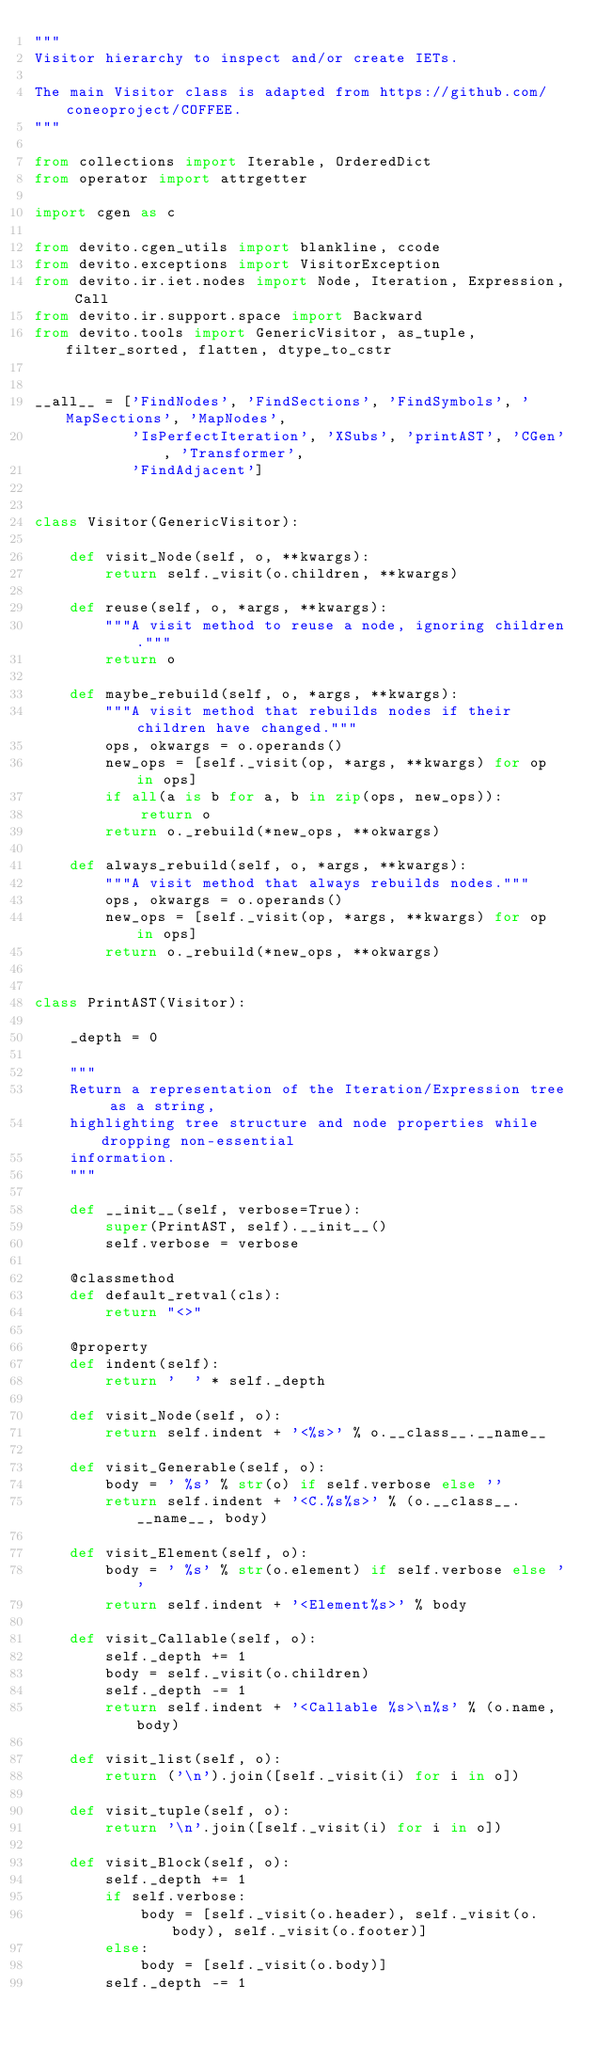Convert code to text. <code><loc_0><loc_0><loc_500><loc_500><_Python_>"""
Visitor hierarchy to inspect and/or create IETs.

The main Visitor class is adapted from https://github.com/coneoproject/COFFEE.
"""

from collections import Iterable, OrderedDict
from operator import attrgetter

import cgen as c

from devito.cgen_utils import blankline, ccode
from devito.exceptions import VisitorException
from devito.ir.iet.nodes import Node, Iteration, Expression, Call
from devito.ir.support.space import Backward
from devito.tools import GenericVisitor, as_tuple, filter_sorted, flatten, dtype_to_cstr


__all__ = ['FindNodes', 'FindSections', 'FindSymbols', 'MapSections', 'MapNodes',
           'IsPerfectIteration', 'XSubs', 'printAST', 'CGen', 'Transformer',
           'FindAdjacent']


class Visitor(GenericVisitor):

    def visit_Node(self, o, **kwargs):
        return self._visit(o.children, **kwargs)

    def reuse(self, o, *args, **kwargs):
        """A visit method to reuse a node, ignoring children."""
        return o

    def maybe_rebuild(self, o, *args, **kwargs):
        """A visit method that rebuilds nodes if their children have changed."""
        ops, okwargs = o.operands()
        new_ops = [self._visit(op, *args, **kwargs) for op in ops]
        if all(a is b for a, b in zip(ops, new_ops)):
            return o
        return o._rebuild(*new_ops, **okwargs)

    def always_rebuild(self, o, *args, **kwargs):
        """A visit method that always rebuilds nodes."""
        ops, okwargs = o.operands()
        new_ops = [self._visit(op, *args, **kwargs) for op in ops]
        return o._rebuild(*new_ops, **okwargs)


class PrintAST(Visitor):

    _depth = 0

    """
    Return a representation of the Iteration/Expression tree as a string,
    highlighting tree structure and node properties while dropping non-essential
    information.
    """

    def __init__(self, verbose=True):
        super(PrintAST, self).__init__()
        self.verbose = verbose

    @classmethod
    def default_retval(cls):
        return "<>"

    @property
    def indent(self):
        return '  ' * self._depth

    def visit_Node(self, o):
        return self.indent + '<%s>' % o.__class__.__name__

    def visit_Generable(self, o):
        body = ' %s' % str(o) if self.verbose else ''
        return self.indent + '<C.%s%s>' % (o.__class__.__name__, body)

    def visit_Element(self, o):
        body = ' %s' % str(o.element) if self.verbose else ''
        return self.indent + '<Element%s>' % body

    def visit_Callable(self, o):
        self._depth += 1
        body = self._visit(o.children)
        self._depth -= 1
        return self.indent + '<Callable %s>\n%s' % (o.name, body)

    def visit_list(self, o):
        return ('\n').join([self._visit(i) for i in o])

    def visit_tuple(self, o):
        return '\n'.join([self._visit(i) for i in o])

    def visit_Block(self, o):
        self._depth += 1
        if self.verbose:
            body = [self._visit(o.header), self._visit(o.body), self._visit(o.footer)]
        else:
            body = [self._visit(o.body)]
        self._depth -= 1</code> 